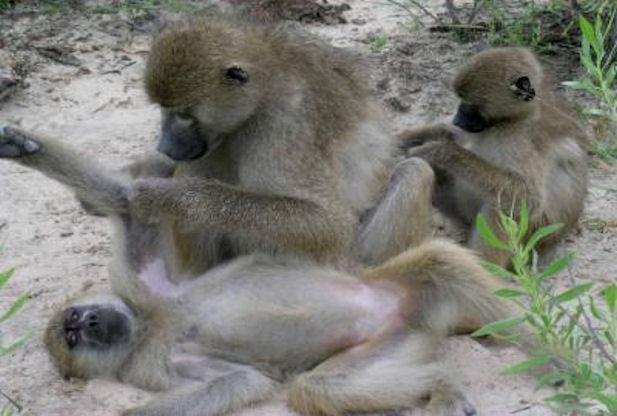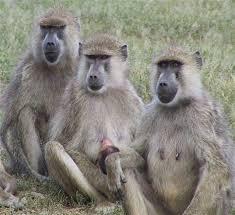The first image is the image on the left, the second image is the image on the right. For the images displayed, is the sentence "A baboon is hugging an animal to its chest in one image." factually correct? Answer yes or no. No. The first image is the image on the left, the second image is the image on the right. Evaluate the accuracy of this statement regarding the images: "In one of the images there is a baby monkey cuddled in the arms of an adult monkey.". Is it true? Answer yes or no. No. 